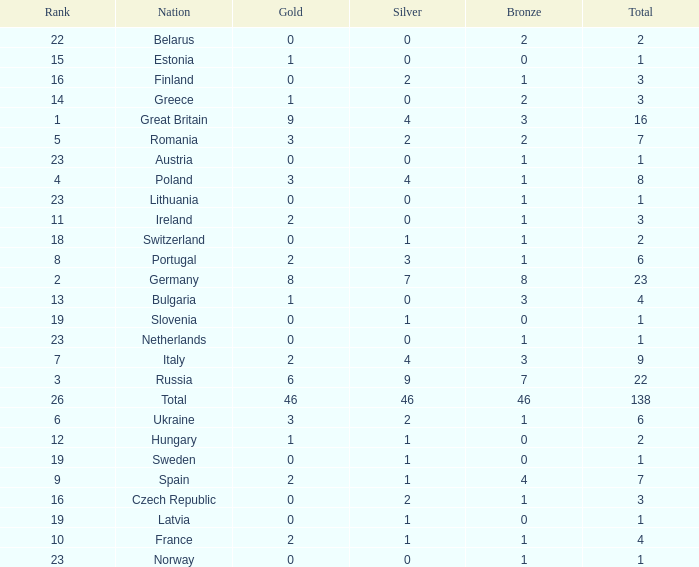When the total is larger than 1,and the bronze is less than 3, and silver larger than 2, and a gold larger than 2, what is the nation? Poland. Would you mind parsing the complete table? {'header': ['Rank', 'Nation', 'Gold', 'Silver', 'Bronze', 'Total'], 'rows': [['22', 'Belarus', '0', '0', '2', '2'], ['15', 'Estonia', '1', '0', '0', '1'], ['16', 'Finland', '0', '2', '1', '3'], ['14', 'Greece', '1', '0', '2', '3'], ['1', 'Great Britain', '9', '4', '3', '16'], ['5', 'Romania', '3', '2', '2', '7'], ['23', 'Austria', '0', '0', '1', '1'], ['4', 'Poland', '3', '4', '1', '8'], ['23', 'Lithuania', '0', '0', '1', '1'], ['11', 'Ireland', '2', '0', '1', '3'], ['18', 'Switzerland', '0', '1', '1', '2'], ['8', 'Portugal', '2', '3', '1', '6'], ['2', 'Germany', '8', '7', '8', '23'], ['13', 'Bulgaria', '1', '0', '3', '4'], ['19', 'Slovenia', '0', '1', '0', '1'], ['23', 'Netherlands', '0', '0', '1', '1'], ['7', 'Italy', '2', '4', '3', '9'], ['3', 'Russia', '6', '9', '7', '22'], ['26', 'Total', '46', '46', '46', '138'], ['6', 'Ukraine', '3', '2', '1', '6'], ['12', 'Hungary', '1', '1', '0', '2'], ['19', 'Sweden', '0', '1', '0', '1'], ['9', 'Spain', '2', '1', '4', '7'], ['16', 'Czech Republic', '0', '2', '1', '3'], ['19', 'Latvia', '0', '1', '0', '1'], ['10', 'France', '2', '1', '1', '4'], ['23', 'Norway', '0', '0', '1', '1']]} 